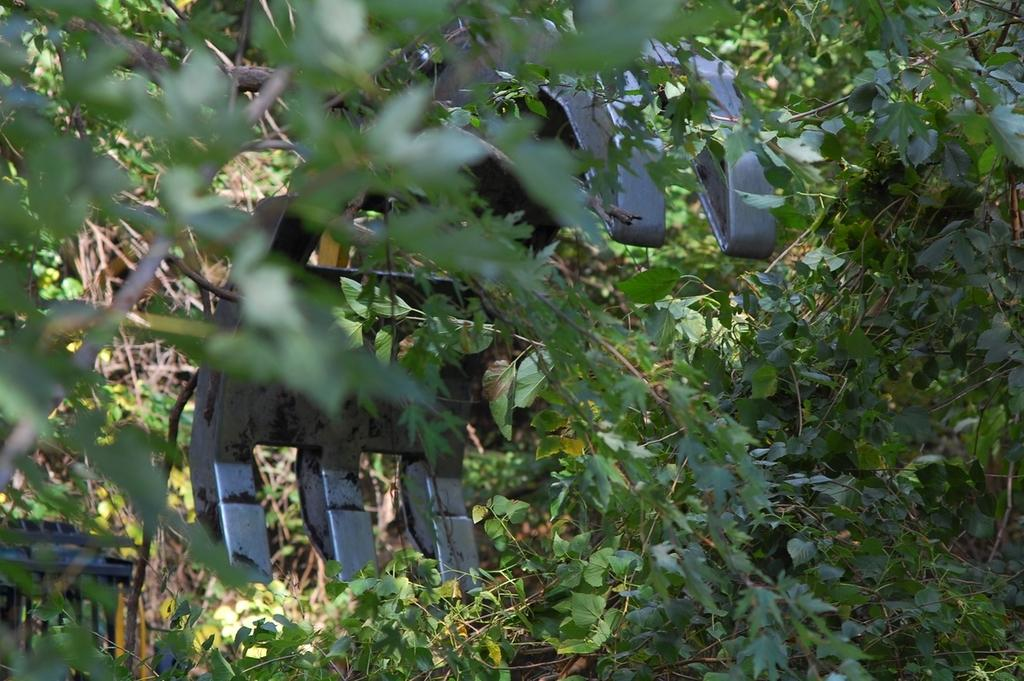What types of living organisms are in the image? The image contains plants. What tool is present in the image? There is a metal cutter with six blades in the image. What year is depicted in the image? The image does not depict a specific year; it only contains plants and a metal cutter. Can you hear the plants crying in the image? Plants do not have the ability to cry, so there are no sounds of crying in the image. 